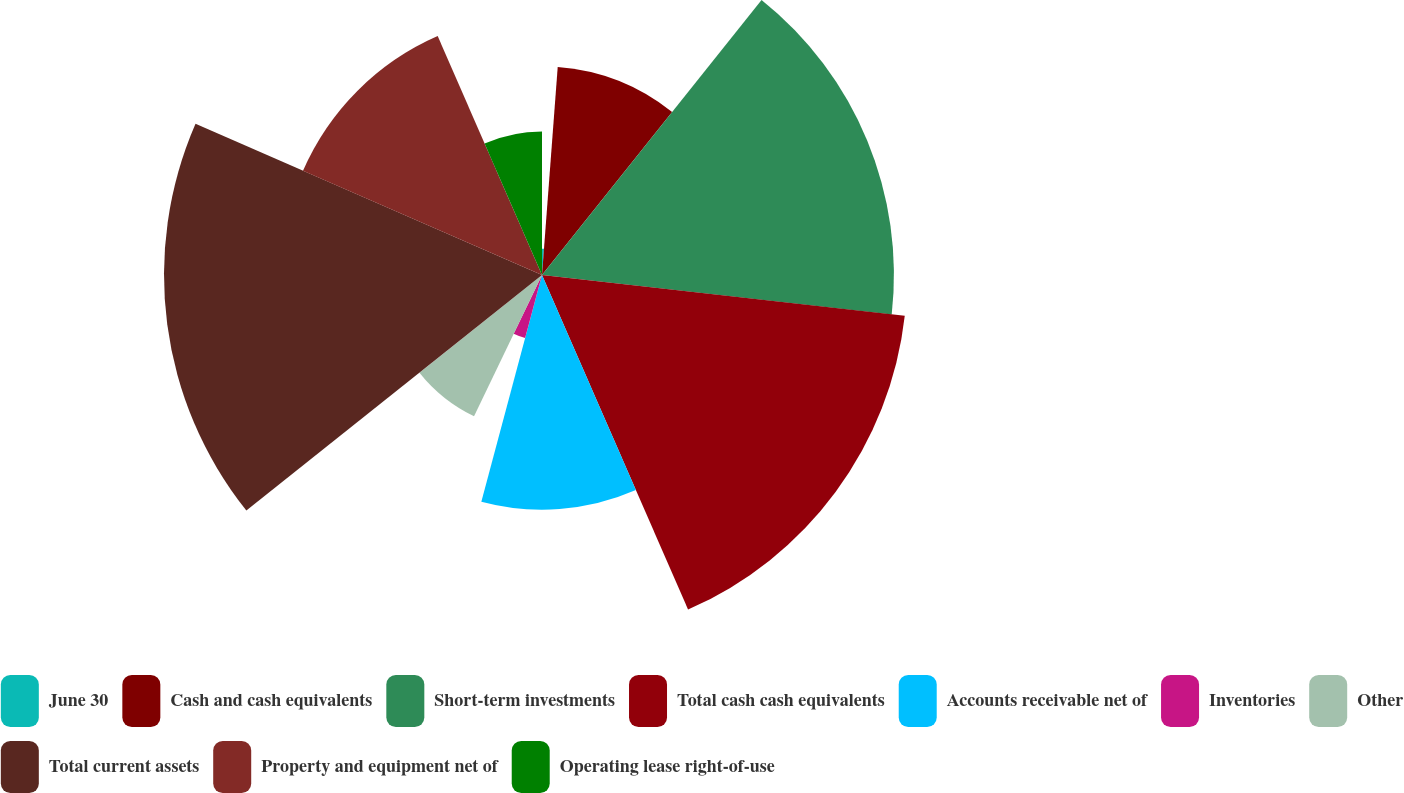Convert chart. <chart><loc_0><loc_0><loc_500><loc_500><pie_chart><fcel>June 30<fcel>Cash and cash equivalents<fcel>Short-term investments<fcel>Total cash cash equivalents<fcel>Accounts receivable net of<fcel>Inventories<fcel>Other<fcel>Total current assets<fcel>Property and equipment net of<fcel>Operating lease right-of-use<nl><fcel>1.2%<fcel>9.52%<fcel>16.06%<fcel>16.66%<fcel>10.71%<fcel>2.98%<fcel>7.15%<fcel>17.25%<fcel>11.9%<fcel>6.55%<nl></chart> 